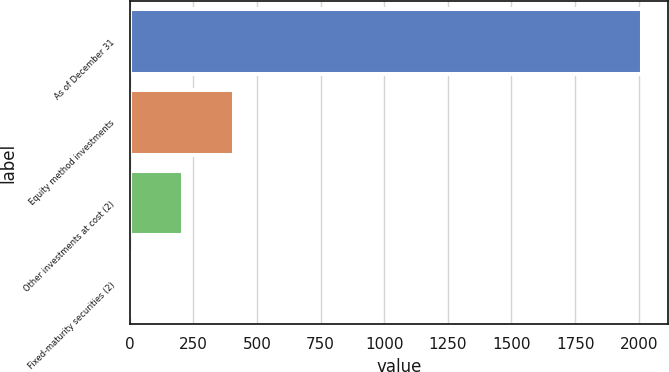Convert chart. <chart><loc_0><loc_0><loc_500><loc_500><bar_chart><fcel>As of December 31<fcel>Equity method investments<fcel>Other investments at cost (2)<fcel>Fixed-maturity securities (2)<nl><fcel>2013<fcel>409.8<fcel>209.4<fcel>9<nl></chart> 